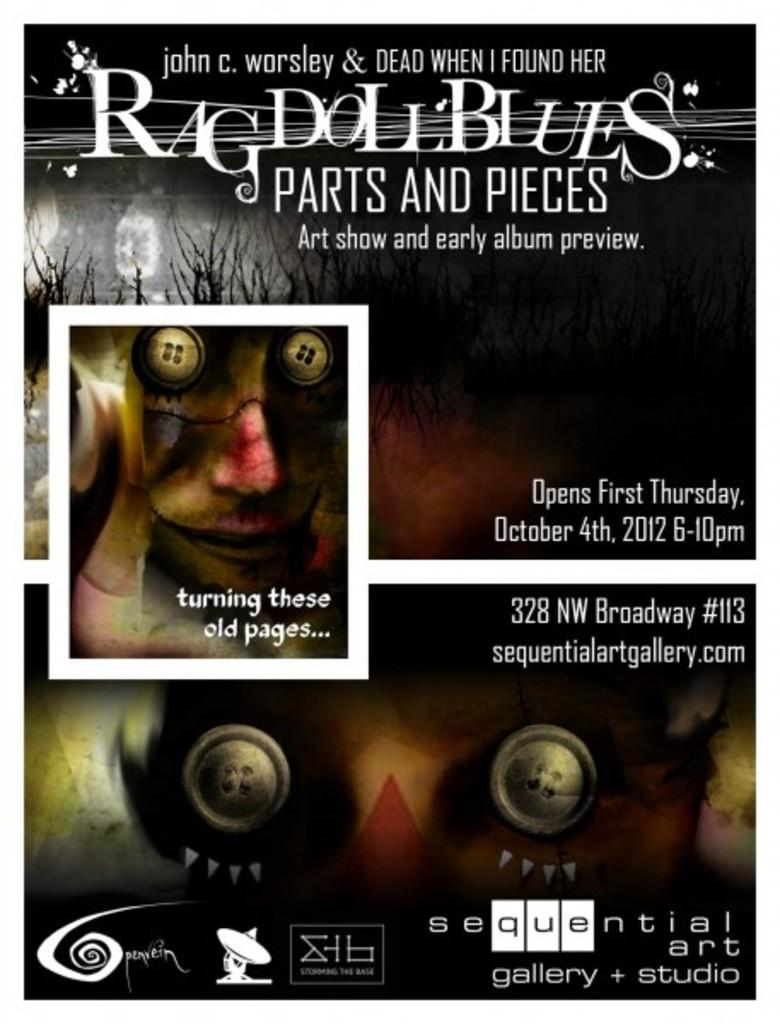What is the color of the object in the image? The object in the image is black. What type of object is it? It is a poster. What can be found on the poster besides the picture of a person? The poster contains text, numbers, and pictures of other objects. What type of bead is used to create the person's necklace in the image? There is no person or necklace present in the image, so it is not possible to determine the type of bead used. How does the hook contribute to the society depicted in the image? There is no hook or society depicted in the image, so it is not possible to determine the hook's contribution to any society. 